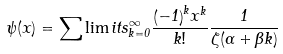<formula> <loc_0><loc_0><loc_500><loc_500>\psi ( x ) = \sum \lim i t s _ { k = 0 } ^ { \infty } \frac { { \left ( - 1 \right ) } ^ { k } x ^ { k } } { k ! } \frac { 1 } { \zeta ( \alpha + \beta k ) }</formula> 